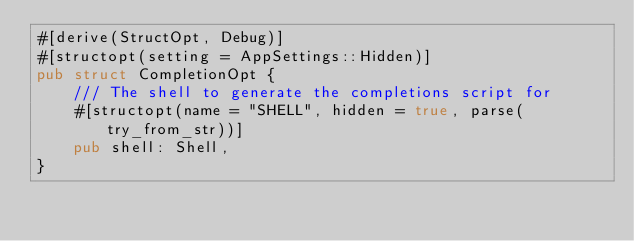Convert code to text. <code><loc_0><loc_0><loc_500><loc_500><_Rust_>#[derive(StructOpt, Debug)]
#[structopt(setting = AppSettings::Hidden)]
pub struct CompletionOpt {
    /// The shell to generate the completions script for
    #[structopt(name = "SHELL", hidden = true, parse(try_from_str))]
    pub shell: Shell,
}
</code> 